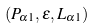Convert formula to latex. <formula><loc_0><loc_0><loc_500><loc_500>( P _ { \alpha 1 } , \varepsilon , L _ { \alpha 1 } )</formula> 